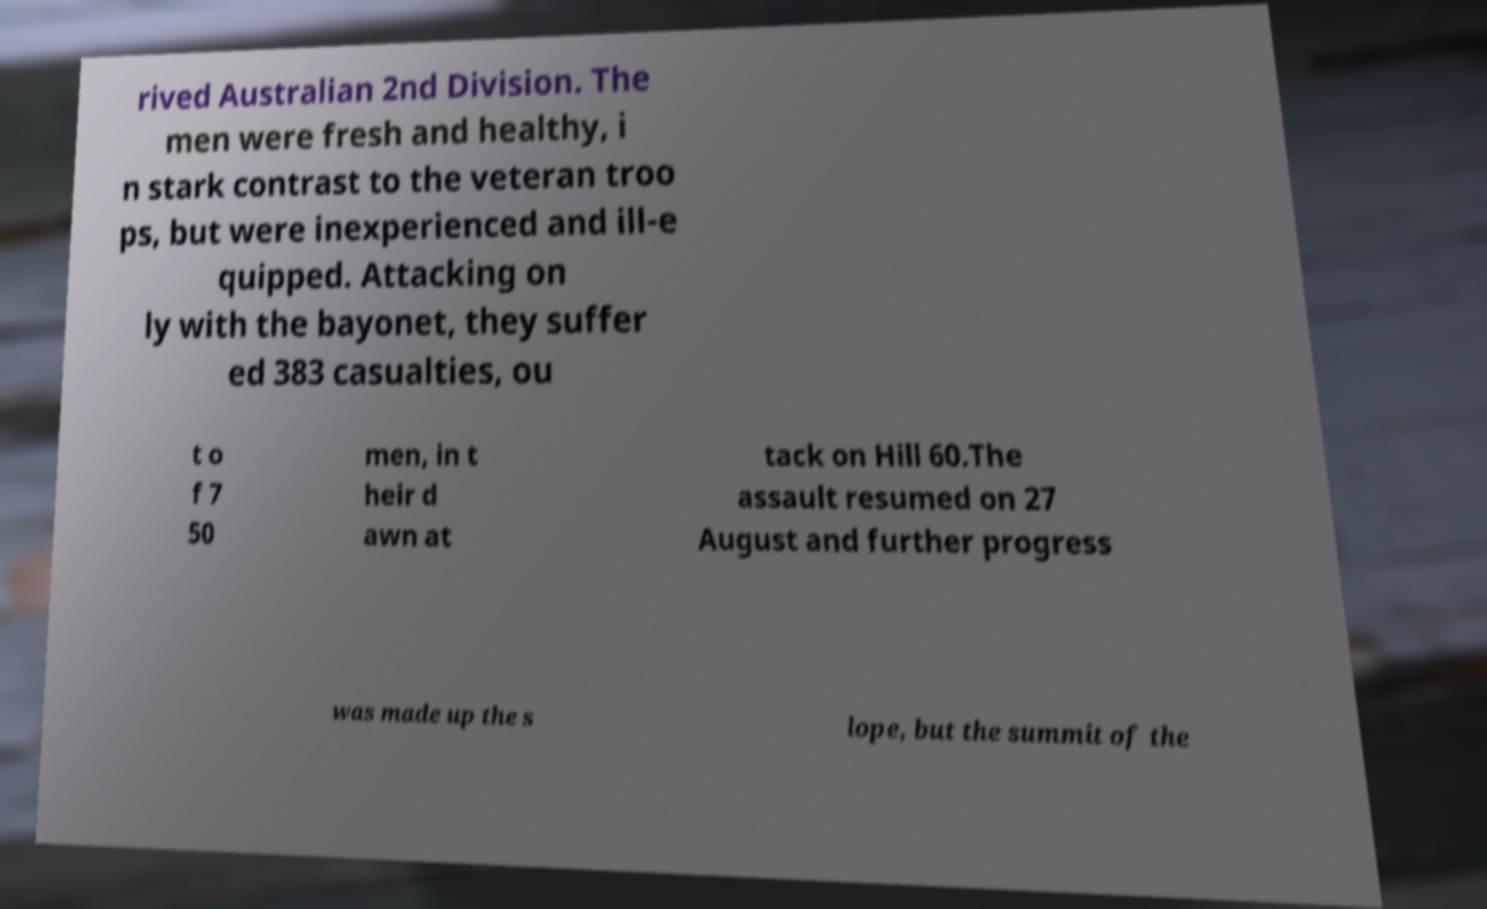Please identify and transcribe the text found in this image. rived Australian 2nd Division. The men were fresh and healthy, i n stark contrast to the veteran troo ps, but were inexperienced and ill-e quipped. Attacking on ly with the bayonet, they suffer ed 383 casualties, ou t o f 7 50 men, in t heir d awn at tack on Hill 60.The assault resumed on 27 August and further progress was made up the s lope, but the summit of the 